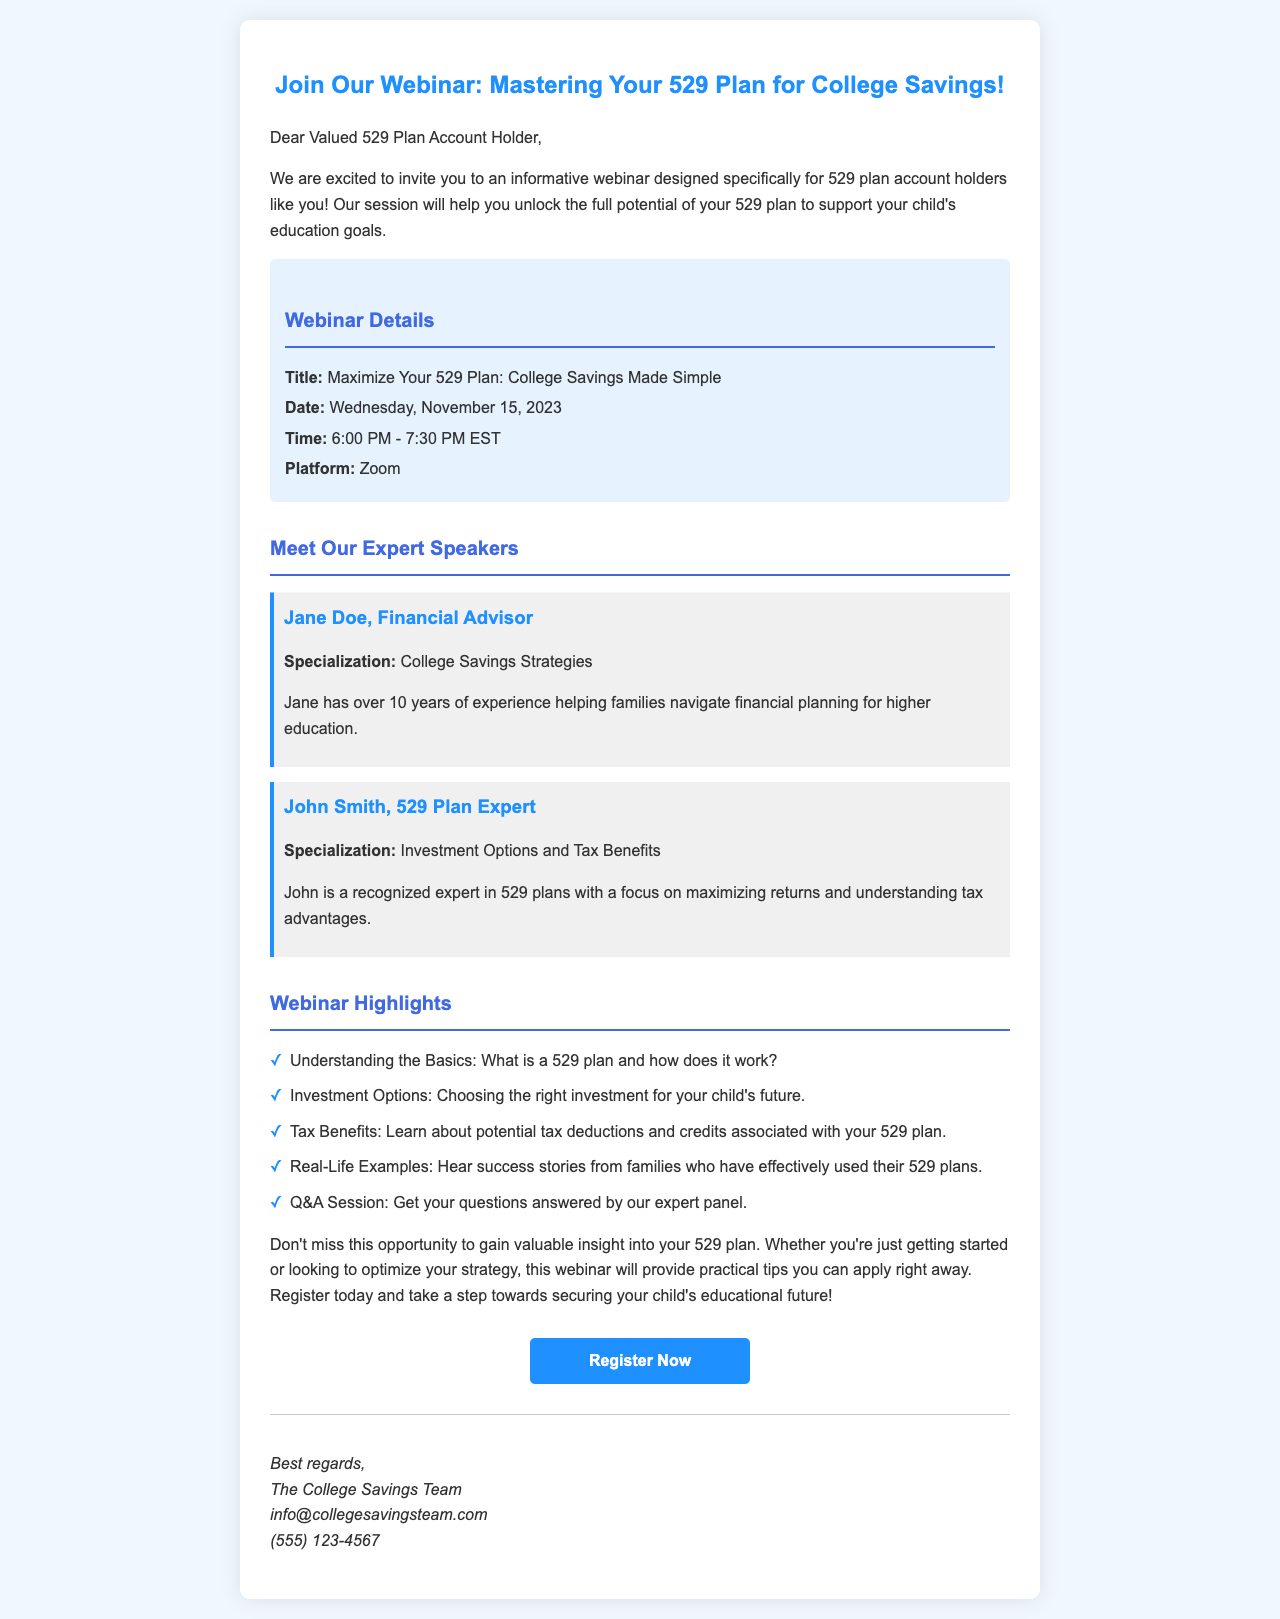What is the title of the webinar? The title of the webinar is provided in the document as part of the webinar details.
Answer: Maximize Your 529 Plan: College Savings Made Simple When is the webinar scheduled? The date of the webinar is mentioned clearly in the details section of the document, indicating when it will take place.
Answer: Wednesday, November 15, 2023 Who is a speaker at the webinar? The document lists two expert speakers, and mentioning one of their names answers the question.
Answer: Jane Doe What time does the webinar start? The document specifies the time of the webinar in the details section.
Answer: 6:00 PM What platform will the webinar be held on? The platform for the webinar is explicitly stated in the document's webinar details section.
Answer: Zoom What is one of the highlights of the webinar? The document lists several highlights, and naming one provides the information needed.
Answer: Understanding the Basics: What is a 529 plan and how does it work? How long is the webinar scheduled to last? The duration of the webinar is indicated by the start and end times provided in the document.
Answer: 1.5 hours What is the contact email for the College Savings Team? The document includes a signature section that provides the contact information, including the email address.
Answer: info@collegesavingsteam.com 